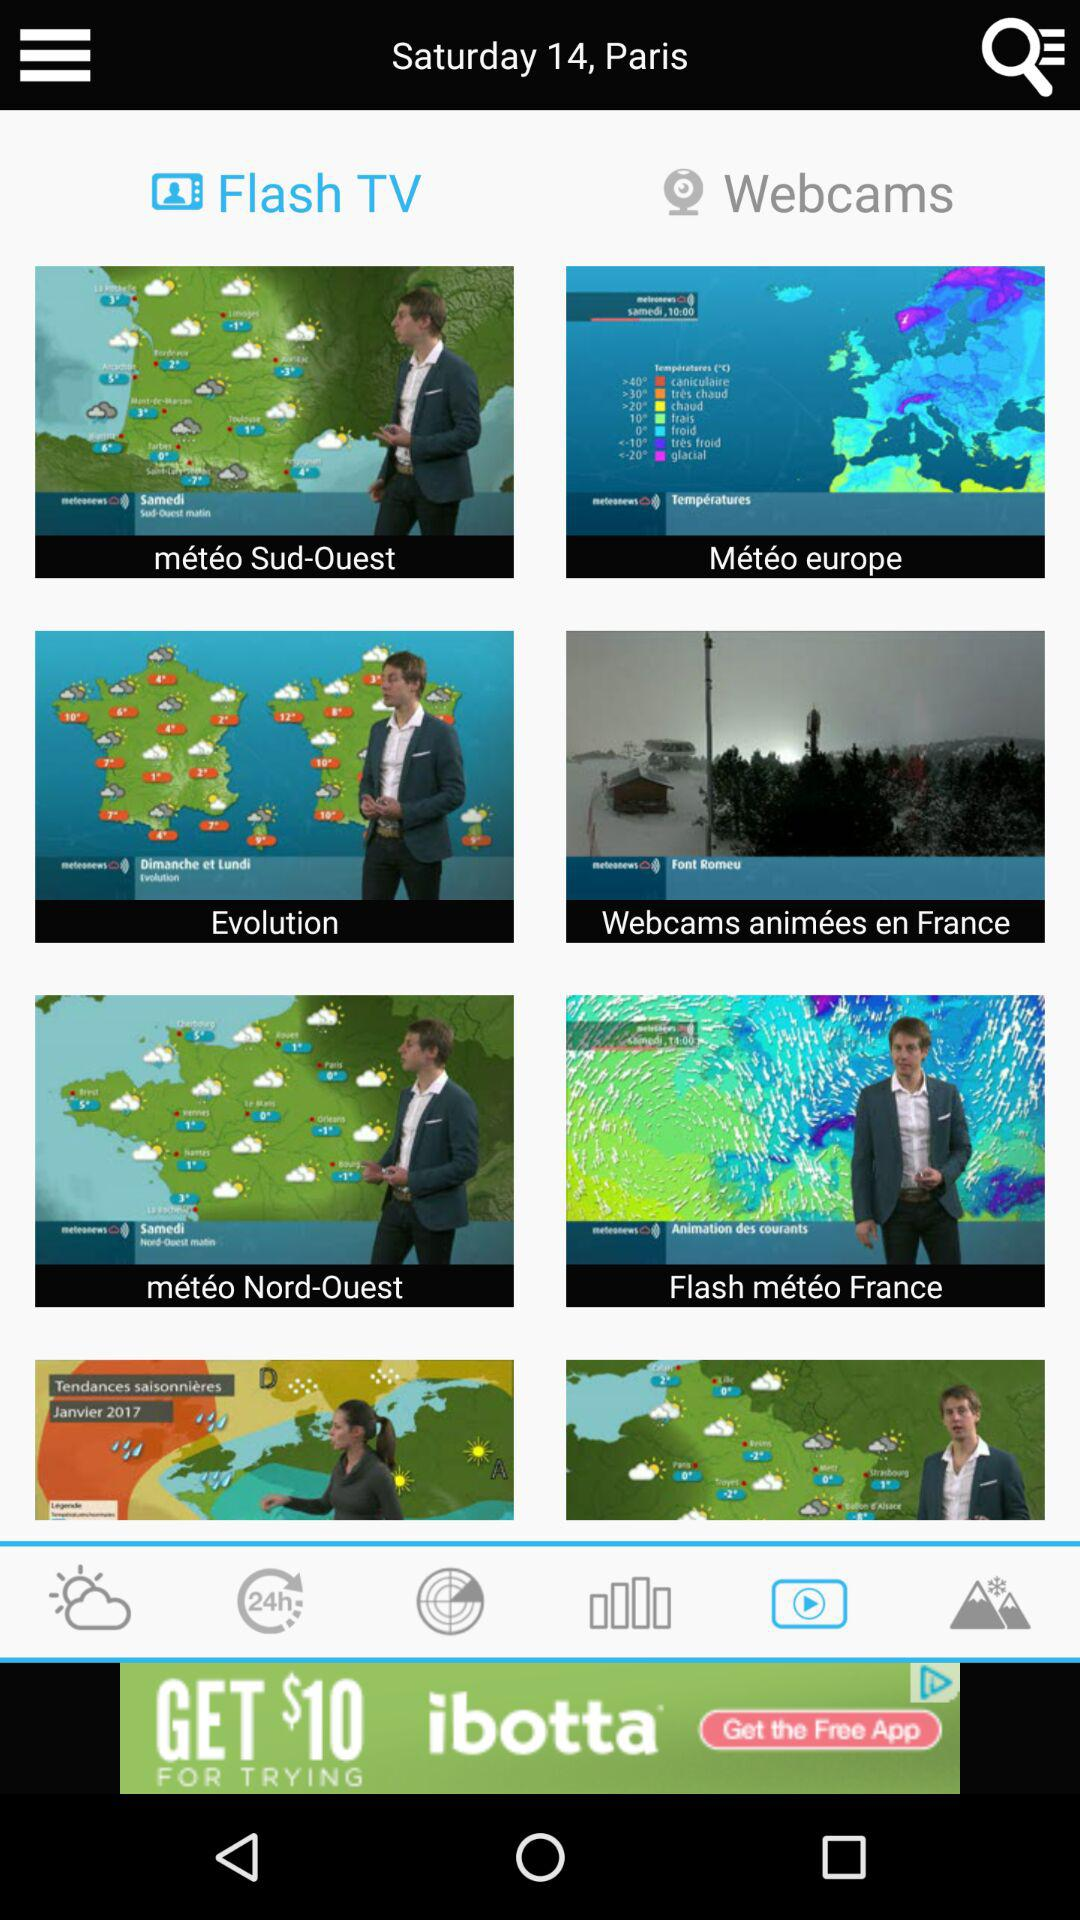What is the location? The location is Paris. 